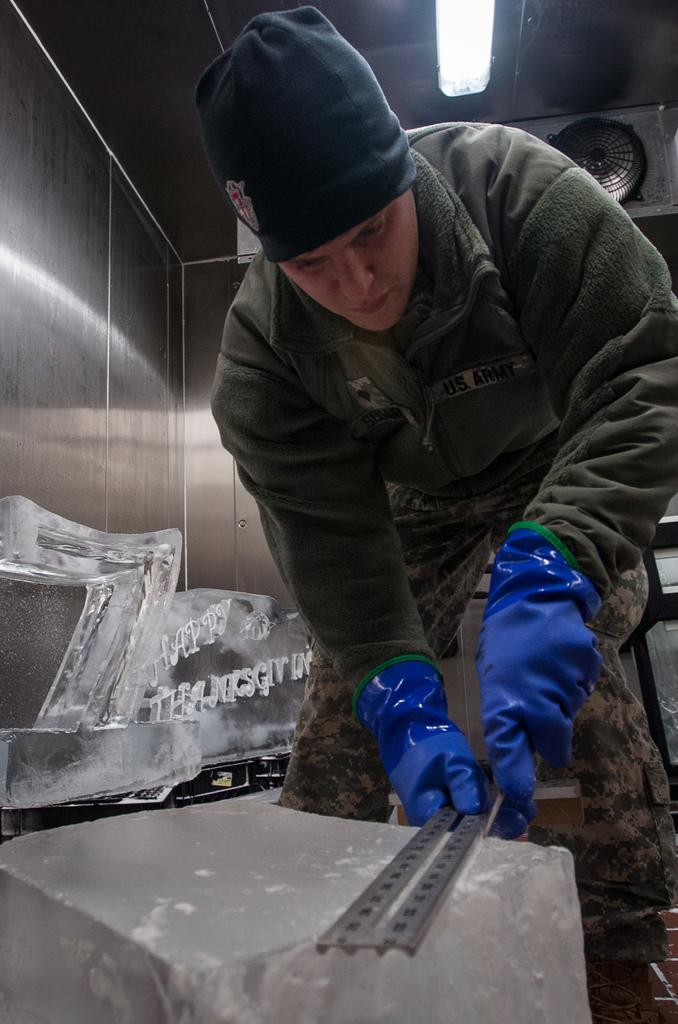What is the man in the image doing? The man is standing in the image and holding an object. Can you describe the object the man is holding? The object may be an ice sculpture. What type of lighting is visible in the image? There is a tube light visible at the top of the image. What other object can be seen at the top of the image? There is an exhaust fan visible at the top of the image. What type of lumber is the man using to build a farm in the image? There is no lumber or farm present in the image; it features a man holding an object that may be an ice sculpture. 